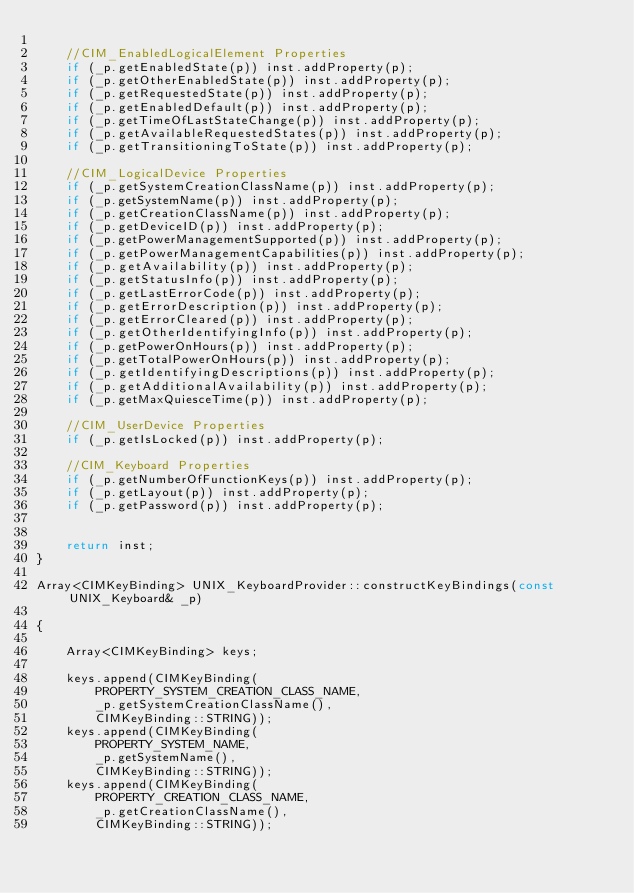<code> <loc_0><loc_0><loc_500><loc_500><_C++_>
	//CIM_EnabledLogicalElement Properties
	if (_p.getEnabledState(p)) inst.addProperty(p);
	if (_p.getOtherEnabledState(p)) inst.addProperty(p);
	if (_p.getRequestedState(p)) inst.addProperty(p);
	if (_p.getEnabledDefault(p)) inst.addProperty(p);
	if (_p.getTimeOfLastStateChange(p)) inst.addProperty(p);
	if (_p.getAvailableRequestedStates(p)) inst.addProperty(p);
	if (_p.getTransitioningToState(p)) inst.addProperty(p);

	//CIM_LogicalDevice Properties
	if (_p.getSystemCreationClassName(p)) inst.addProperty(p);
	if (_p.getSystemName(p)) inst.addProperty(p);
	if (_p.getCreationClassName(p)) inst.addProperty(p);
	if (_p.getDeviceID(p)) inst.addProperty(p);
	if (_p.getPowerManagementSupported(p)) inst.addProperty(p);
	if (_p.getPowerManagementCapabilities(p)) inst.addProperty(p);
	if (_p.getAvailability(p)) inst.addProperty(p);
	if (_p.getStatusInfo(p)) inst.addProperty(p);
	if (_p.getLastErrorCode(p)) inst.addProperty(p);
	if (_p.getErrorDescription(p)) inst.addProperty(p);
	if (_p.getErrorCleared(p)) inst.addProperty(p);
	if (_p.getOtherIdentifyingInfo(p)) inst.addProperty(p);
	if (_p.getPowerOnHours(p)) inst.addProperty(p);
	if (_p.getTotalPowerOnHours(p)) inst.addProperty(p);
	if (_p.getIdentifyingDescriptions(p)) inst.addProperty(p);
	if (_p.getAdditionalAvailability(p)) inst.addProperty(p);
	if (_p.getMaxQuiesceTime(p)) inst.addProperty(p);

	//CIM_UserDevice Properties
	if (_p.getIsLocked(p)) inst.addProperty(p);

	//CIM_Keyboard Properties
	if (_p.getNumberOfFunctionKeys(p)) inst.addProperty(p);
	if (_p.getLayout(p)) inst.addProperty(p);
	if (_p.getPassword(p)) inst.addProperty(p);


	return inst;
}

Array<CIMKeyBinding> UNIX_KeyboardProvider::constructKeyBindings(const UNIX_Keyboard& _p)

{

	Array<CIMKeyBinding> keys;

	keys.append(CIMKeyBinding(
		PROPERTY_SYSTEM_CREATION_CLASS_NAME,
		_p.getSystemCreationClassName(),
		CIMKeyBinding::STRING));
	keys.append(CIMKeyBinding(
		PROPERTY_SYSTEM_NAME,
		_p.getSystemName(),
		CIMKeyBinding::STRING));
	keys.append(CIMKeyBinding(
		PROPERTY_CREATION_CLASS_NAME,
		_p.getCreationClassName(),
		CIMKeyBinding::STRING));</code> 